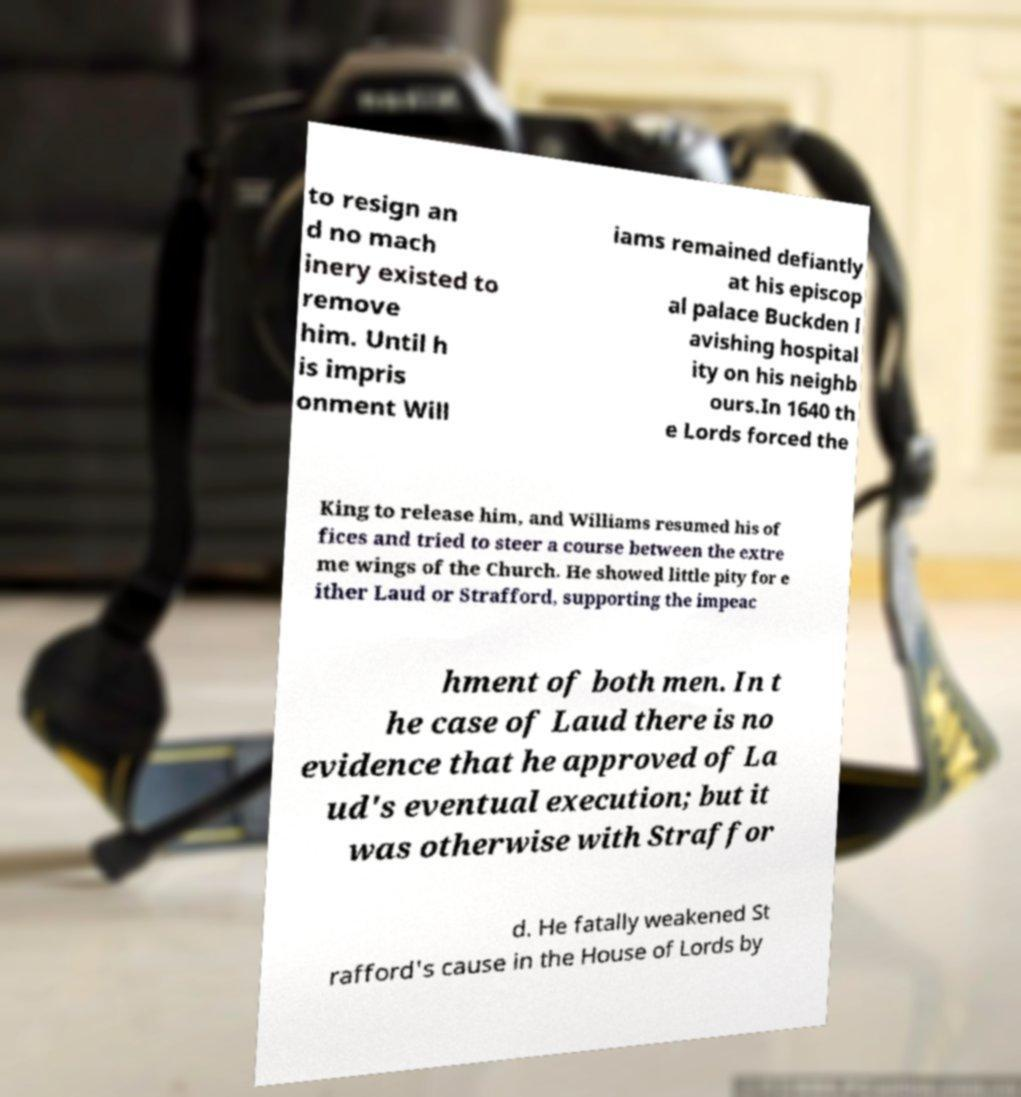Please read and relay the text visible in this image. What does it say? to resign an d no mach inery existed to remove him. Until h is impris onment Will iams remained defiantly at his episcop al palace Buckden l avishing hospital ity on his neighb ours.In 1640 th e Lords forced the King to release him, and Williams resumed his of fices and tried to steer a course between the extre me wings of the Church. He showed little pity for e ither Laud or Strafford, supporting the impeac hment of both men. In t he case of Laud there is no evidence that he approved of La ud's eventual execution; but it was otherwise with Straffor d. He fatally weakened St rafford's cause in the House of Lords by 